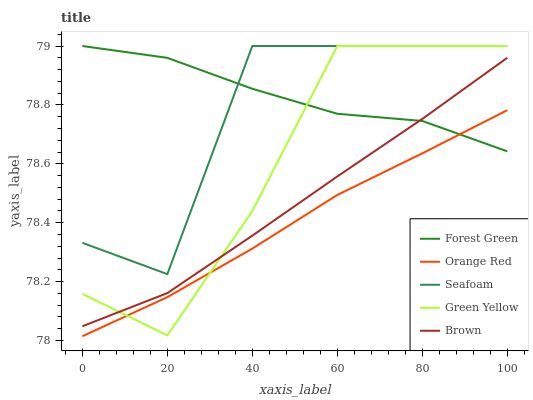Does Orange Red have the minimum area under the curve?
Answer yes or no. Yes. Does Forest Green have the maximum area under the curve?
Answer yes or no. Yes. Does Green Yellow have the minimum area under the curve?
Answer yes or no. No. Does Green Yellow have the maximum area under the curve?
Answer yes or no. No. Is Orange Red the smoothest?
Answer yes or no. Yes. Is Seafoam the roughest?
Answer yes or no. Yes. Is Forest Green the smoothest?
Answer yes or no. No. Is Forest Green the roughest?
Answer yes or no. No. Does Orange Red have the lowest value?
Answer yes or no. Yes. Does Green Yellow have the lowest value?
Answer yes or no. No. Does Seafoam have the highest value?
Answer yes or no. Yes. Does Orange Red have the highest value?
Answer yes or no. No. Is Brown less than Seafoam?
Answer yes or no. Yes. Is Seafoam greater than Brown?
Answer yes or no. Yes. Does Green Yellow intersect Forest Green?
Answer yes or no. Yes. Is Green Yellow less than Forest Green?
Answer yes or no. No. Is Green Yellow greater than Forest Green?
Answer yes or no. No. Does Brown intersect Seafoam?
Answer yes or no. No. 